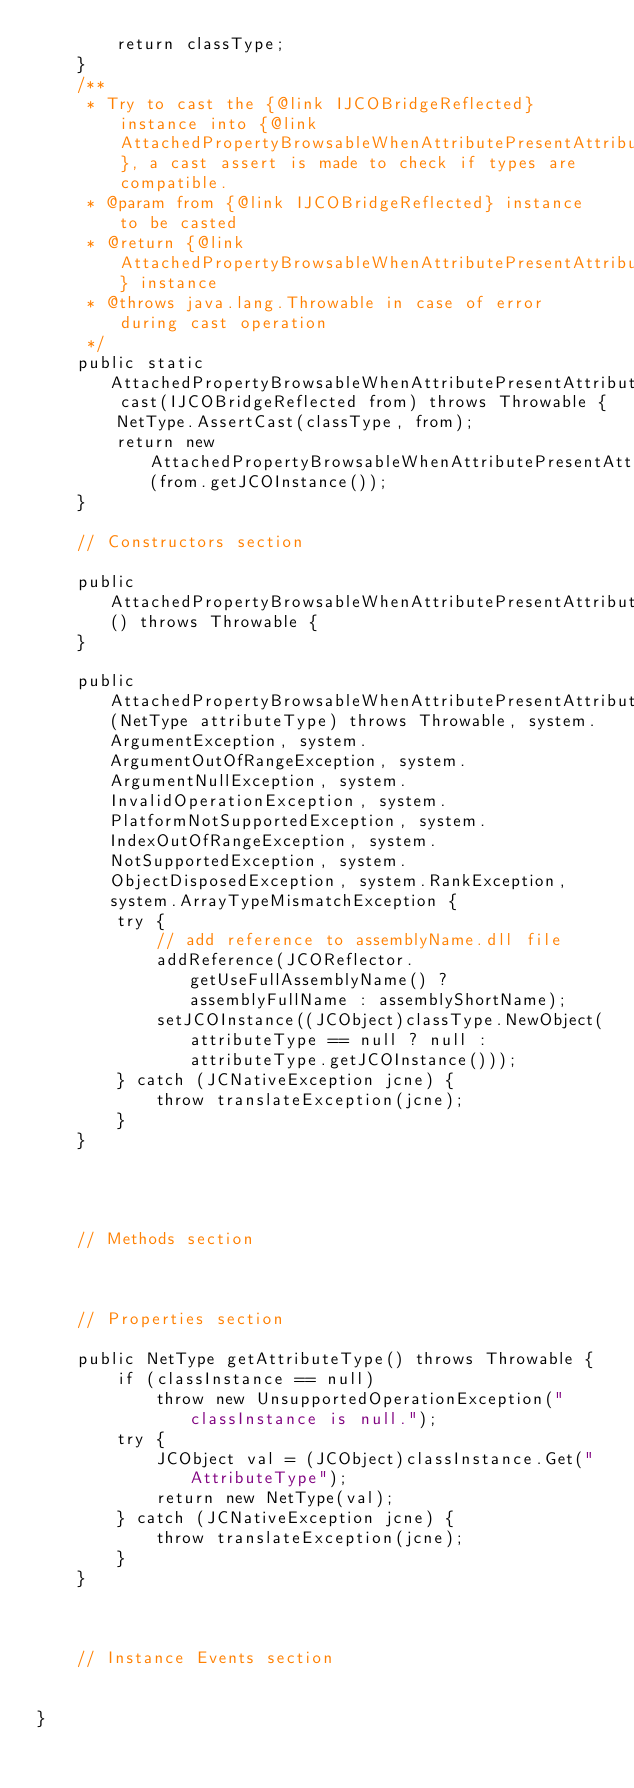Convert code to text. <code><loc_0><loc_0><loc_500><loc_500><_Java_>        return classType;
    }
    /**
     * Try to cast the {@link IJCOBridgeReflected} instance into {@link AttachedPropertyBrowsableWhenAttributePresentAttribute}, a cast assert is made to check if types are compatible.
     * @param from {@link IJCOBridgeReflected} instance to be casted
     * @return {@link AttachedPropertyBrowsableWhenAttributePresentAttribute} instance
     * @throws java.lang.Throwable in case of error during cast operation
     */
    public static AttachedPropertyBrowsableWhenAttributePresentAttribute cast(IJCOBridgeReflected from) throws Throwable {
        NetType.AssertCast(classType, from);
        return new AttachedPropertyBrowsableWhenAttributePresentAttribute(from.getJCOInstance());
    }

    // Constructors section
    
    public AttachedPropertyBrowsableWhenAttributePresentAttribute() throws Throwable {
    }

    public AttachedPropertyBrowsableWhenAttributePresentAttribute(NetType attributeType) throws Throwable, system.ArgumentException, system.ArgumentOutOfRangeException, system.ArgumentNullException, system.InvalidOperationException, system.PlatformNotSupportedException, system.IndexOutOfRangeException, system.NotSupportedException, system.ObjectDisposedException, system.RankException, system.ArrayTypeMismatchException {
        try {
            // add reference to assemblyName.dll file
            addReference(JCOReflector.getUseFullAssemblyName() ? assemblyFullName : assemblyShortName);
            setJCOInstance((JCObject)classType.NewObject(attributeType == null ? null : attributeType.getJCOInstance()));
        } catch (JCNativeException jcne) {
            throw translateException(jcne);
        }
    }



    
    // Methods section
    

    
    // Properties section
    
    public NetType getAttributeType() throws Throwable {
        if (classInstance == null)
            throw new UnsupportedOperationException("classInstance is null.");
        try {
            JCObject val = (JCObject)classInstance.Get("AttributeType");
            return new NetType(val);
        } catch (JCNativeException jcne) {
            throw translateException(jcne);
        }
    }



    // Instance Events section
    

}</code> 